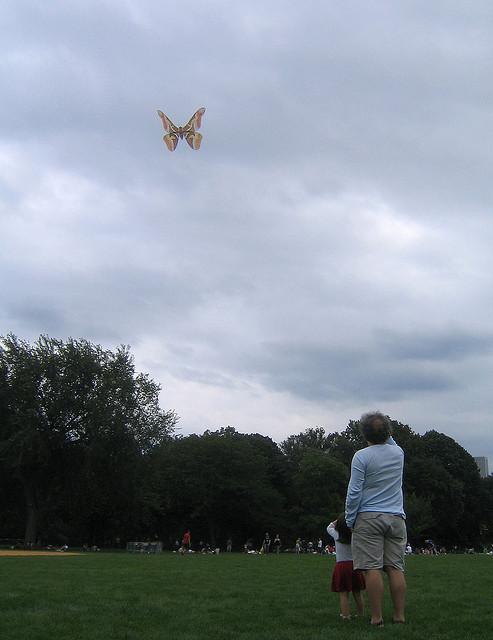Is the weather warm?
Keep it brief. No. What geographic formation is this man standing on?
Write a very short answer. Ground. What does this animal provide to us?
Be succinct. Beauty. What is in  the sky?
Give a very brief answer. Kite. Is that a butterfly in the sky?
Be succinct. Yes. Which direction is the wind blowing?
Give a very brief answer. West. Is a sweater tied around the man's waist?
Be succinct. No. Is it a pleasant day?
Write a very short answer. Yes. Are there an trees in the photo?
Write a very short answer. Yes. What color are the wings of the kite?
Write a very short answer. Yellow. Does the kite have a tail?
Be succinct. No. Where was this photo taken?
Quick response, please. Outside. Is the kite flyer over 18?
Give a very brief answer. Yes. What animal does the kite represent?
Short answer required. Butterfly. What color is the skirt the girl is wearing?
Quick response, please. Red. What color is the kite?
Be succinct. Yellow. In what city is this man flying his kite?
Write a very short answer. Don't know. What continent is this?
Give a very brief answer. North america. What is the weather like?
Concise answer only. Cloudy. Are there trees in the background?
Concise answer only. Yes. Is it a clear day?
Quick response, please. No. 